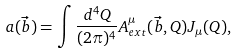Convert formula to latex. <formula><loc_0><loc_0><loc_500><loc_500>a ( \vec { b } ) = \int \frac { d ^ { 4 } Q } { ( 2 \pi ) ^ { 4 } } A _ { e x t } ^ { \mu } ( \vec { b } , Q ) J _ { \mu } ( Q ) ,</formula> 